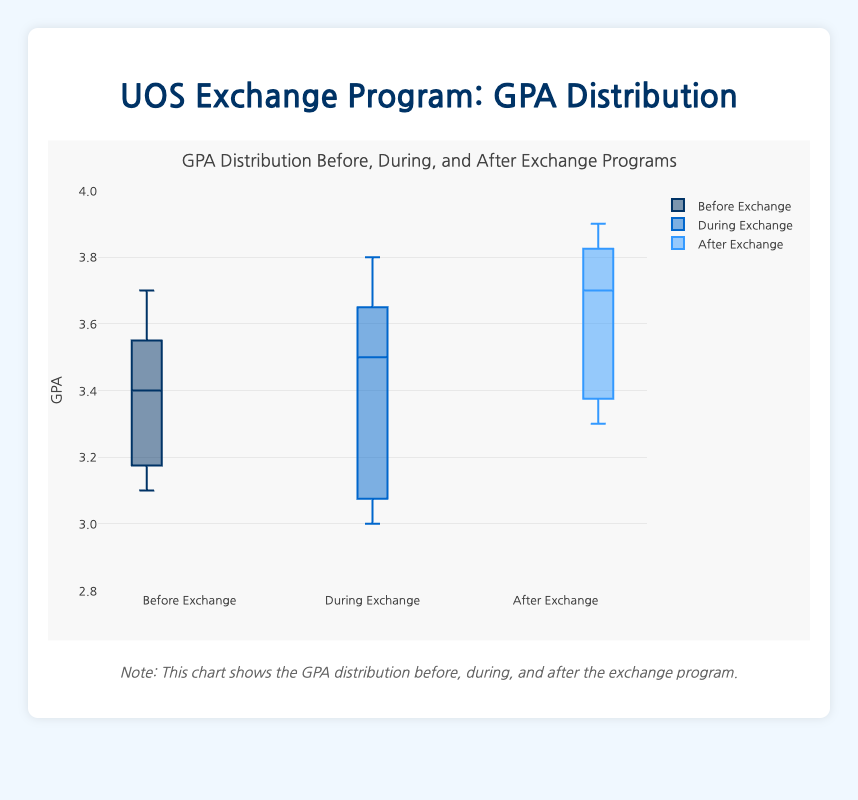How many periods are compared in the box plot? The title and the x-axis labels indicate that there are three periods compared in the box plot: "Before Exchange," "During Exchange," and "After Exchange."
Answer: 3 What is the title of the box plot? The title of the box plot is displayed at the top of the figure and reads "GPA Distribution Before, During, and After Exchange Programs."
Answer: GPA Distribution Before, During, and After Exchange Programs What is the median GPA during the exchange period? The median GPA for the "During Exchange" period is represented by the horizontal line inside the box for that period. By examining this line, we can determine the median GPA.
Answer: 3.5 Which period shows the highest median GPA? By comparing the horizontal lines (medians) inside each box, we can see that the "After Exchange" period has the highest median GPA.
Answer: After Exchange What is the interquartile range (IQR) of the GPA before the exchange program? The IQR is the difference between the first quartile (Q1) and the third quartile (Q3). For the "Before Exchange" period, we locate Q1 and Q3 on the box and calculate the difference.
Answer: 3.3 - 3.1 Does any period have outliers, and if so, which one(s)? To determine the presence of outliers, examine the box plot for any individual points that fall outside the whiskers of the boxes. There are no outliers for any of the periods in the box plot.
Answer: None Which period has the smallest spread of GPA values? The spread of GPA values is indicated by the length of the box and the whiskers. The period with the smallest spread will have the shortest distance between the minimum and maximum values. In this case, the "After Exchange" period has the smallest spread.
Answer: After Exchange What is the general trend of the GPA from before to after the exchange program? Observing the medians, means, and spreads for each period helps identify the trend in GPA. Generally, the median GPA increases from "Before Exchange" to "During Exchange" and further increases in the "After Exchange" period, indicating an overall improving trend in GPA.
Answer: Increasing How does the GPA variability during the exchange period compare to before and after? Variability is indicated by the length of the boxes and whiskers. The "During Exchange" period has a comparable spread to the "Before Exchange" period but shows less variability compared to the "After Exchange" period.
Answer: Less variable than "After Exchange," comparable with "Before Exchange" What is the lowest recorded GPA before the exchange program? The lowest recorded GPA before the exchange program can be found at the bottom of the whisker for the "Before Exchange" period. This value represents the minimum data point within this group.
Answer: 3.1 